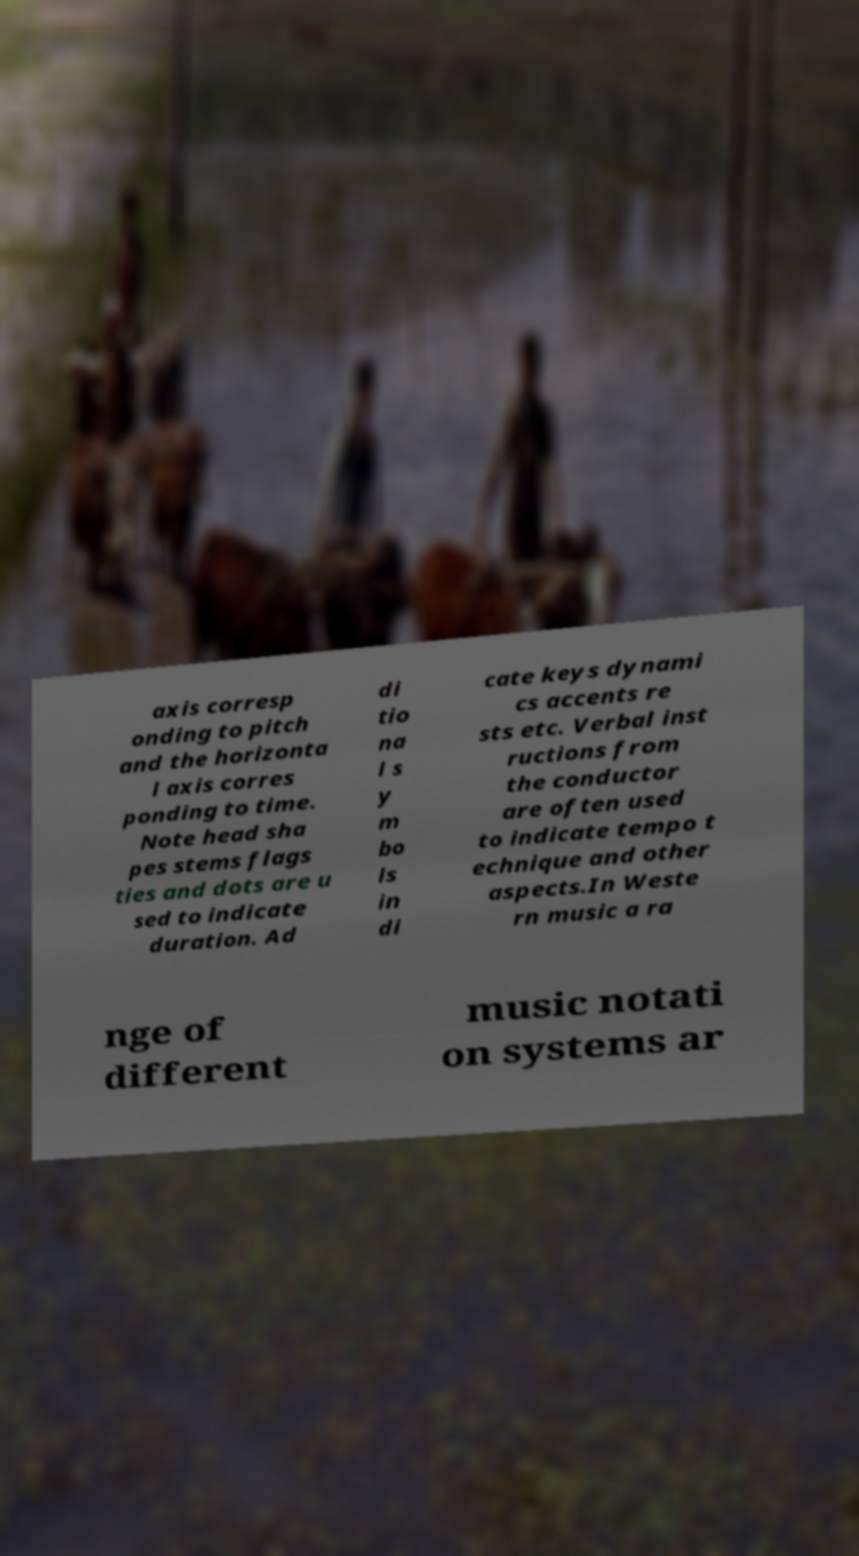Please identify and transcribe the text found in this image. axis corresp onding to pitch and the horizonta l axis corres ponding to time. Note head sha pes stems flags ties and dots are u sed to indicate duration. Ad di tio na l s y m bo ls in di cate keys dynami cs accents re sts etc. Verbal inst ructions from the conductor are often used to indicate tempo t echnique and other aspects.In Weste rn music a ra nge of different music notati on systems ar 